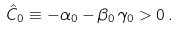Convert formula to latex. <formula><loc_0><loc_0><loc_500><loc_500>\hat { C } _ { 0 } \equiv - \alpha _ { 0 } - \beta _ { 0 } \, \gamma _ { 0 } > 0 \, .</formula> 